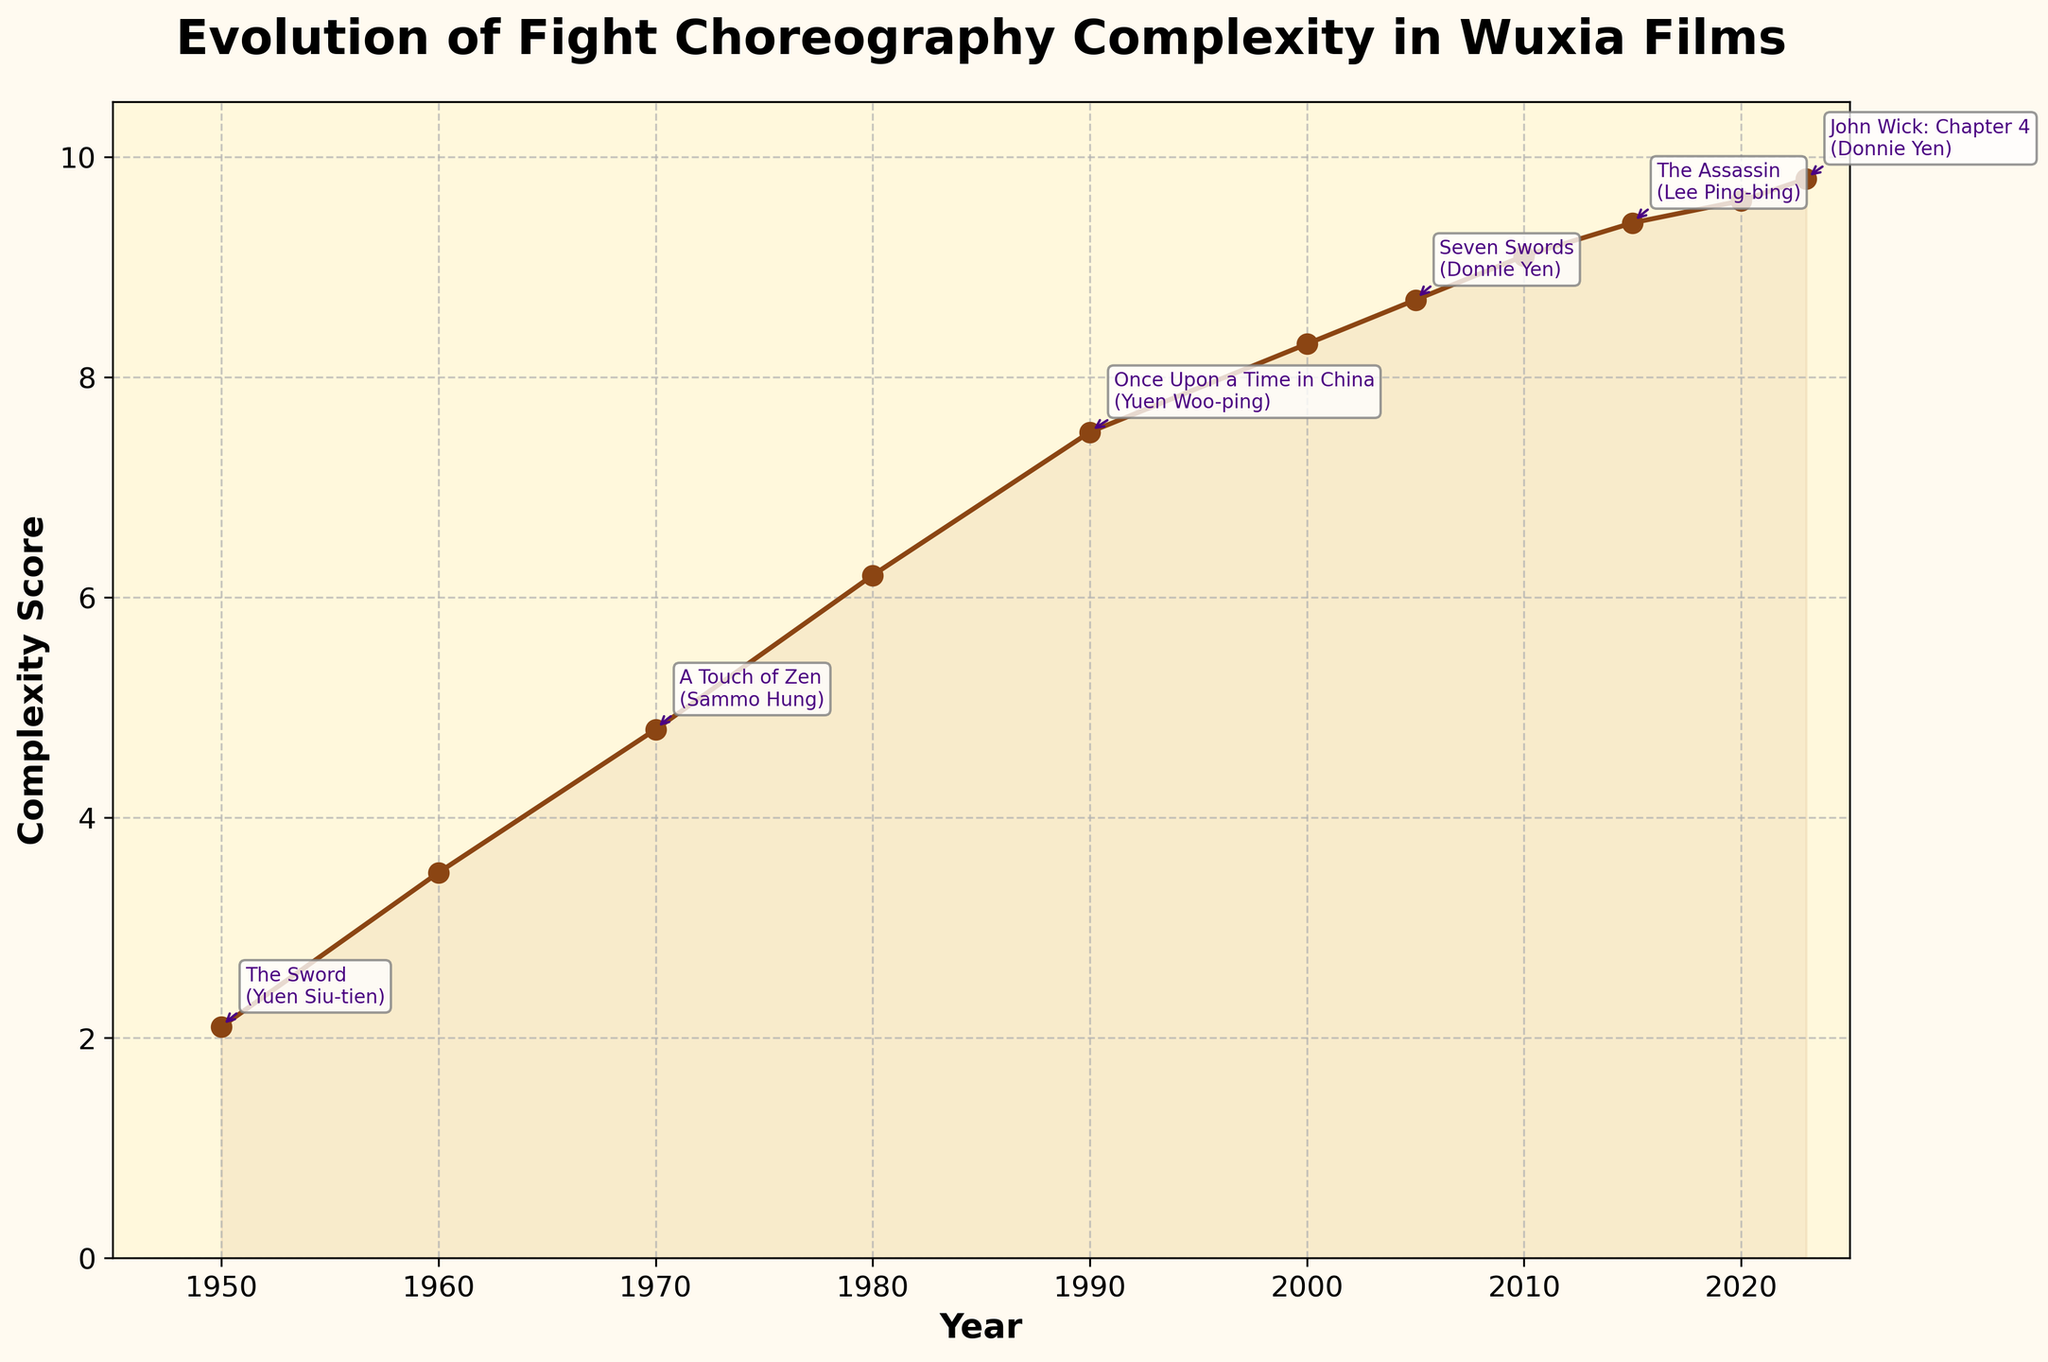How did the complexity score change between 2000 and 2023? From the figure, the complexity score in 2000 was 8.3, and in 2023 it was 9.8. So the change is 9.8 - 8.3 = 1.5.
Answer: 1.5 Which choreographer appears most frequently on the plot? From the annotations in the plot, Yuen Woo-ping appears twice, in 1990 and 2000, more frequently than any other choreographers.
Answer: Yuen Woo-ping During which period did the complexity score see the most significant increase? By looking at the steepness of the line, the period from 1950 to 1980 saw a significant increase from 2.1 to 6.2, which is an increase of 4.1.
Answer: 1950 to 1980 What's the complexity score difference between 'Come Drink with Me' and 'Seven Swords'? From the figure, the complexity score of 'Come Drink with Me' is 3.5, and 'Seven Swords' is 8.7, so the difference is 8.7 - 3.5 = 5.2.
Answer: 5.2 Which film and choreographer correspond to the highest complexity score in the chart? From the plot, the highest complexity score is 9.8 in 2023, corresponding to 'John Wick: Chapter 4' choreographed by Donnie Yen.
Answer: 'John Wick: Chapter 4' and Donnie Yen Is there any year where the complexity score remained the same as the previous year? Checking the plot, the complexity score continuously increases each year without any flat trends.
Answer: No What's the average complexity score from 1950 to 2023? Summing all the scores: 2.1 + 3.5 + 4.8 + 6.2 + 7.5 + 8.3 + 8.7 + 9.1 + 9.4 + 9.6 + 9.8 = 78, and dividing by the number of years (11) gives an average of 78/11 ≈ 7.1.
Answer: 7.1 Which year had the lowest complexity score, and what was the score? The plot shows that 1950 had the lowest complexity score, which was 2.1.
Answer: 1950 and 2.1 